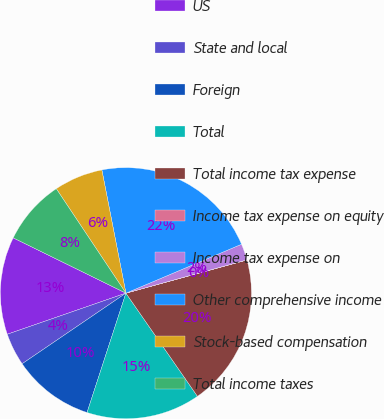Convert chart. <chart><loc_0><loc_0><loc_500><loc_500><pie_chart><fcel>US<fcel>State and local<fcel>Foreign<fcel>Total<fcel>Total income tax expense<fcel>Income tax expense on equity<fcel>Income tax expense on<fcel>Other comprehensive income<fcel>Stock-based compensation<fcel>Total income taxes<nl><fcel>12.57%<fcel>4.2%<fcel>10.48%<fcel>14.66%<fcel>19.61%<fcel>0.01%<fcel>2.1%<fcel>21.7%<fcel>6.29%<fcel>8.38%<nl></chart> 